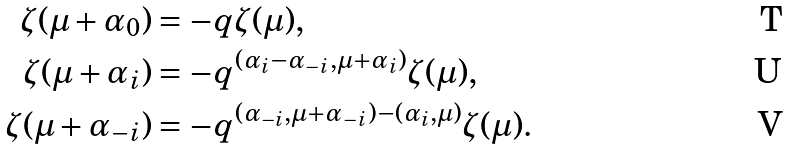<formula> <loc_0><loc_0><loc_500><loc_500>\zeta ( \mu + \alpha _ { 0 } ) & = - q \zeta ( \mu ) , \\ \zeta ( \mu + \alpha _ { i } ) & = - q ^ { ( \alpha _ { i } - \alpha _ { - i } , \mu + \alpha _ { i } ) } \zeta ( \mu ) , \\ \zeta ( \mu + \alpha _ { - i } ) & = - q ^ { ( \alpha _ { - i } , \mu + \alpha _ { - i } ) - ( \alpha _ { i } , \mu ) } \zeta ( \mu ) .</formula> 